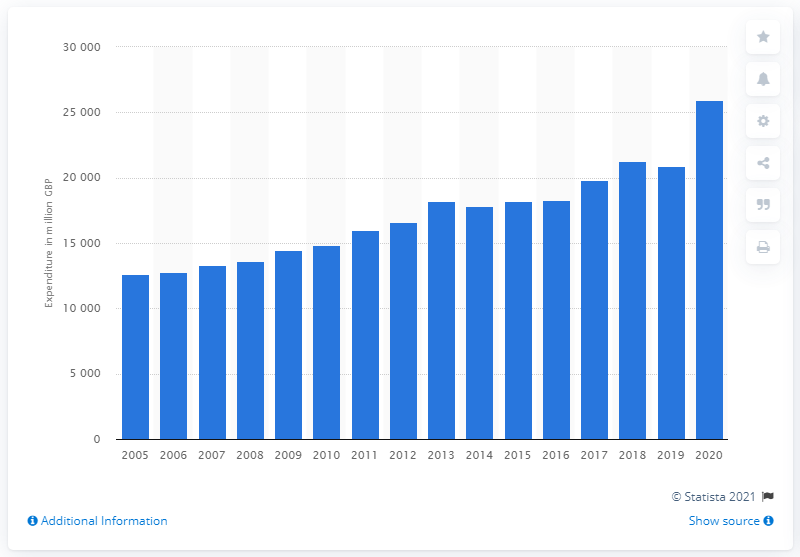What was the amount of British pounds spent on alcoholic drinks in 2020? Based on the bar chart shown, the expenditure on alcoholic drinks in British pounds for the year 2020 amounts to approximately 25,900 million GBP. The chart displays a progressive increase in spending over the years, with 2020 marking the highest expenditure recorded in the displayed range. 